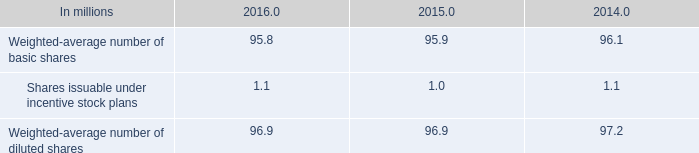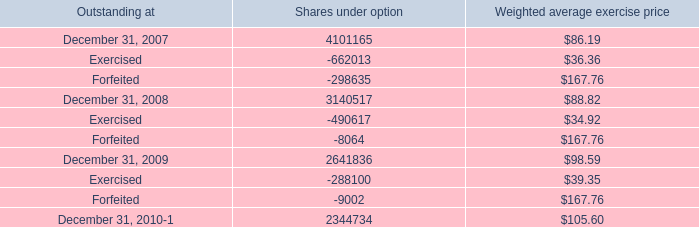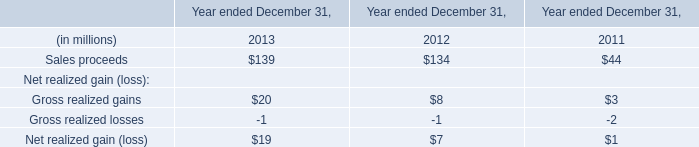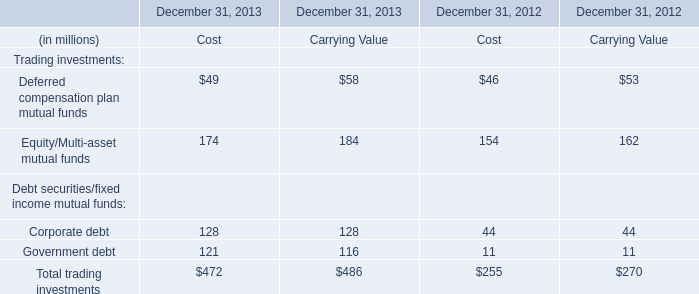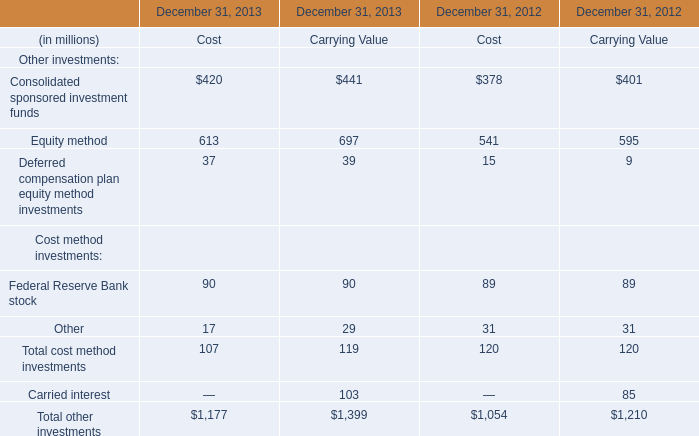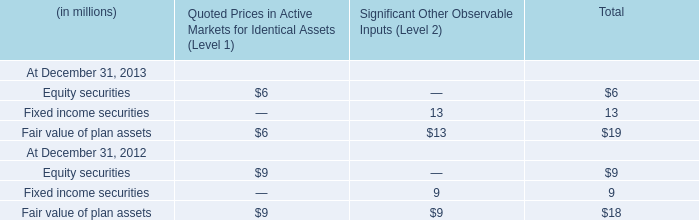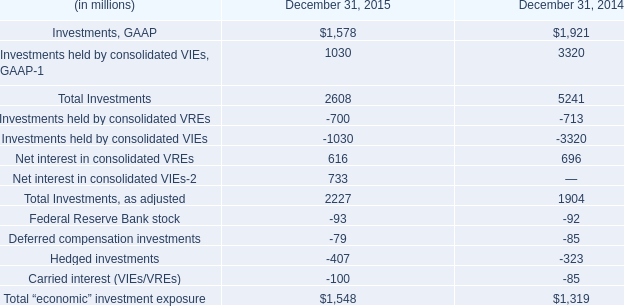What will Corporate debt be like in 2014 if it continues to grow at the same rate as it did in 2013? (in millions) 
Computations: (exp((1 + ((128 - 44) / 44)) * 2))
Answer: 1083.23967. 